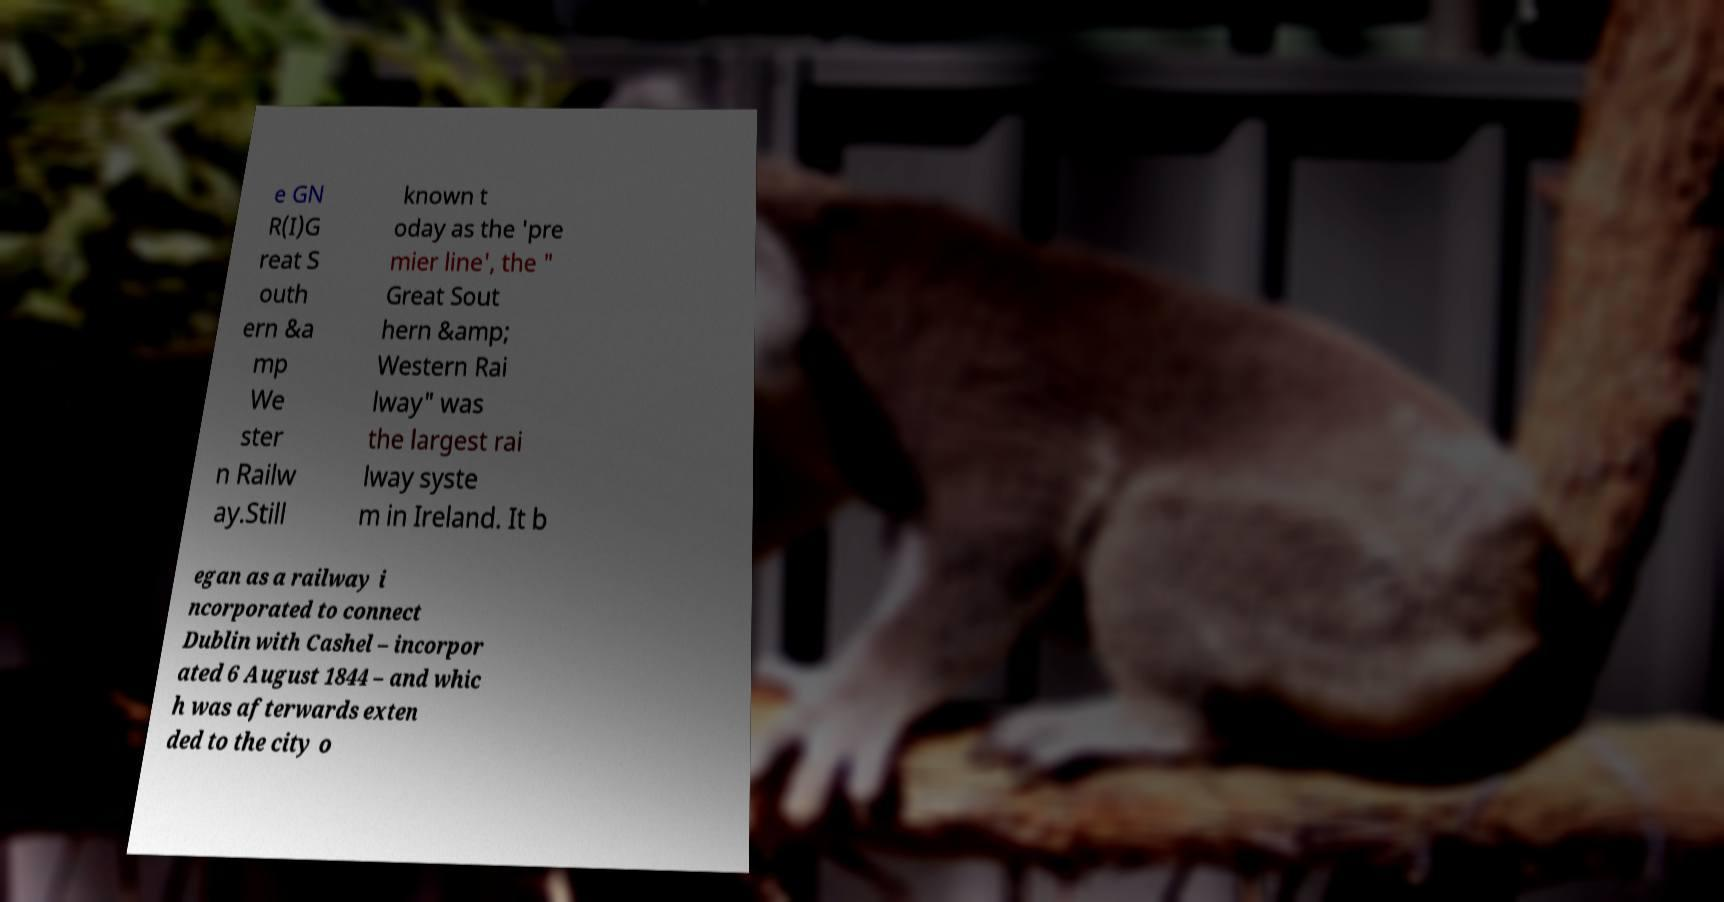Could you assist in decoding the text presented in this image and type it out clearly? e GN R(I)G reat S outh ern &a mp We ster n Railw ay.Still known t oday as the 'pre mier line', the " Great Sout hern &amp; Western Rai lway" was the largest rai lway syste m in Ireland. It b egan as a railway i ncorporated to connect Dublin with Cashel – incorpor ated 6 August 1844 – and whic h was afterwards exten ded to the city o 